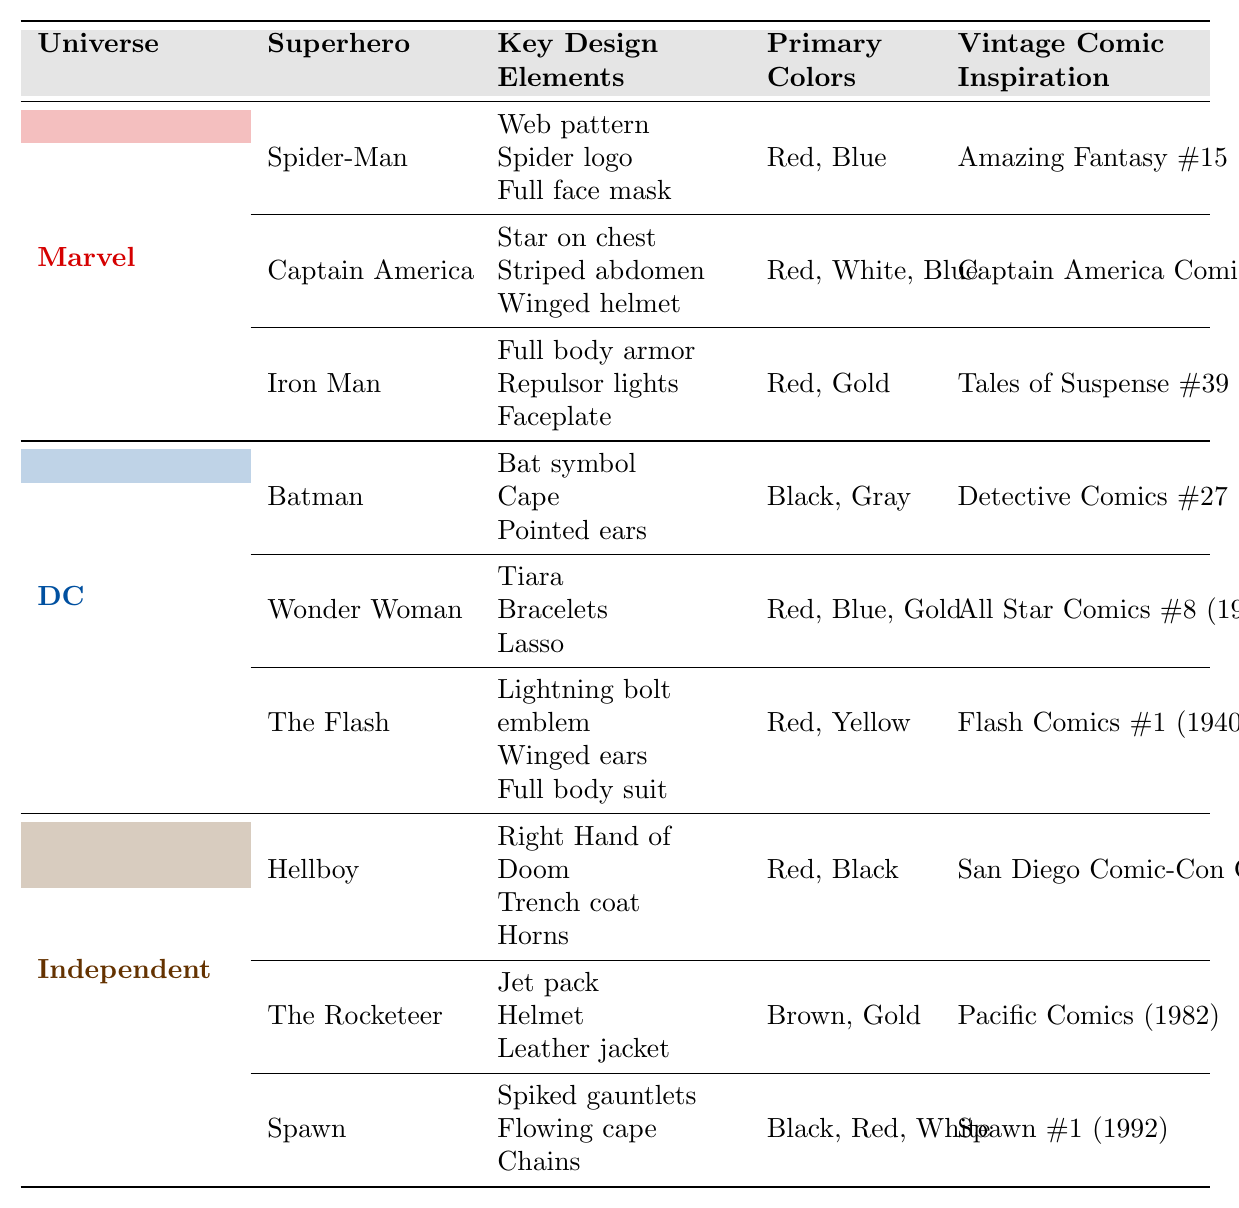What are the key design elements of Spider-Man's costume? According to the table, Spider-Man's key design elements are listed as "Web pattern," "Spider logo," and "Full face mask."
Answer: Web pattern, Spider logo, Full face mask Which superhero has a costume primarily composed of red, white, and blue? The table shows Captain America's primary colors as "Red, White, Blue." Thus, Captain America is the superhero with these colors.
Answer: Captain America Is Batman's costume inspired by the vintage comic "Detective Comics #27"? The table indicates that Batman's vintage comic inspiration is indeed "Detective Comics #27 (1939)." Therefore, the statement is true.
Answer: Yes Which superhero has the most key design elements listed? Both Spider-Man and Captain America have three key design elements each, while all others have three as well. Since they are equal, the result is that no superhero has more than three elements.
Answer: None (they all have three) What is the total number of primary colors used by Wonder Woman and The Flash combined? Wonder Woman's primary colors are "Red, Blue, Gold" (3 colors) and The Flash's primary colors are "Red, Yellow" (2 colors). Adding these, 3 + 2 = 5.
Answer: 5 What is the vintage comic inspiration for Iron Man? The table states that Iron Man's vintage comic inspiration is "Tales of Suspense #39 (1963)."
Answer: Tales of Suspense #39 (1963) Are all the superheroes in the Independent category primarily using red in their costumes? Hellboy uses red and black, The Rocketeer uses brown and gold, and Spawn uses black, red, and white. Since The Rocketeer does not use red, the statement is false.
Answer: No Which superhero has the unique design element of a "jet pack"? The table identifies "Jet pack" as a key design element of The Rocketeer.
Answer: The Rocketeer How many unique primary colors are featured across all the superheroes? Compiling all unique primary colors from the table: Red, Blue, Gold, White, Black, Gray, Yellow, and Brown gives us a total of eight unique colors.
Answer: 8 What design element is shared between Spider-Man and Iron Man's costumes? The table shows that both superheroes have elements related to their unique identities but no direct overlap in design elements is present. Therefore, there is no shared design element.
Answer: None 